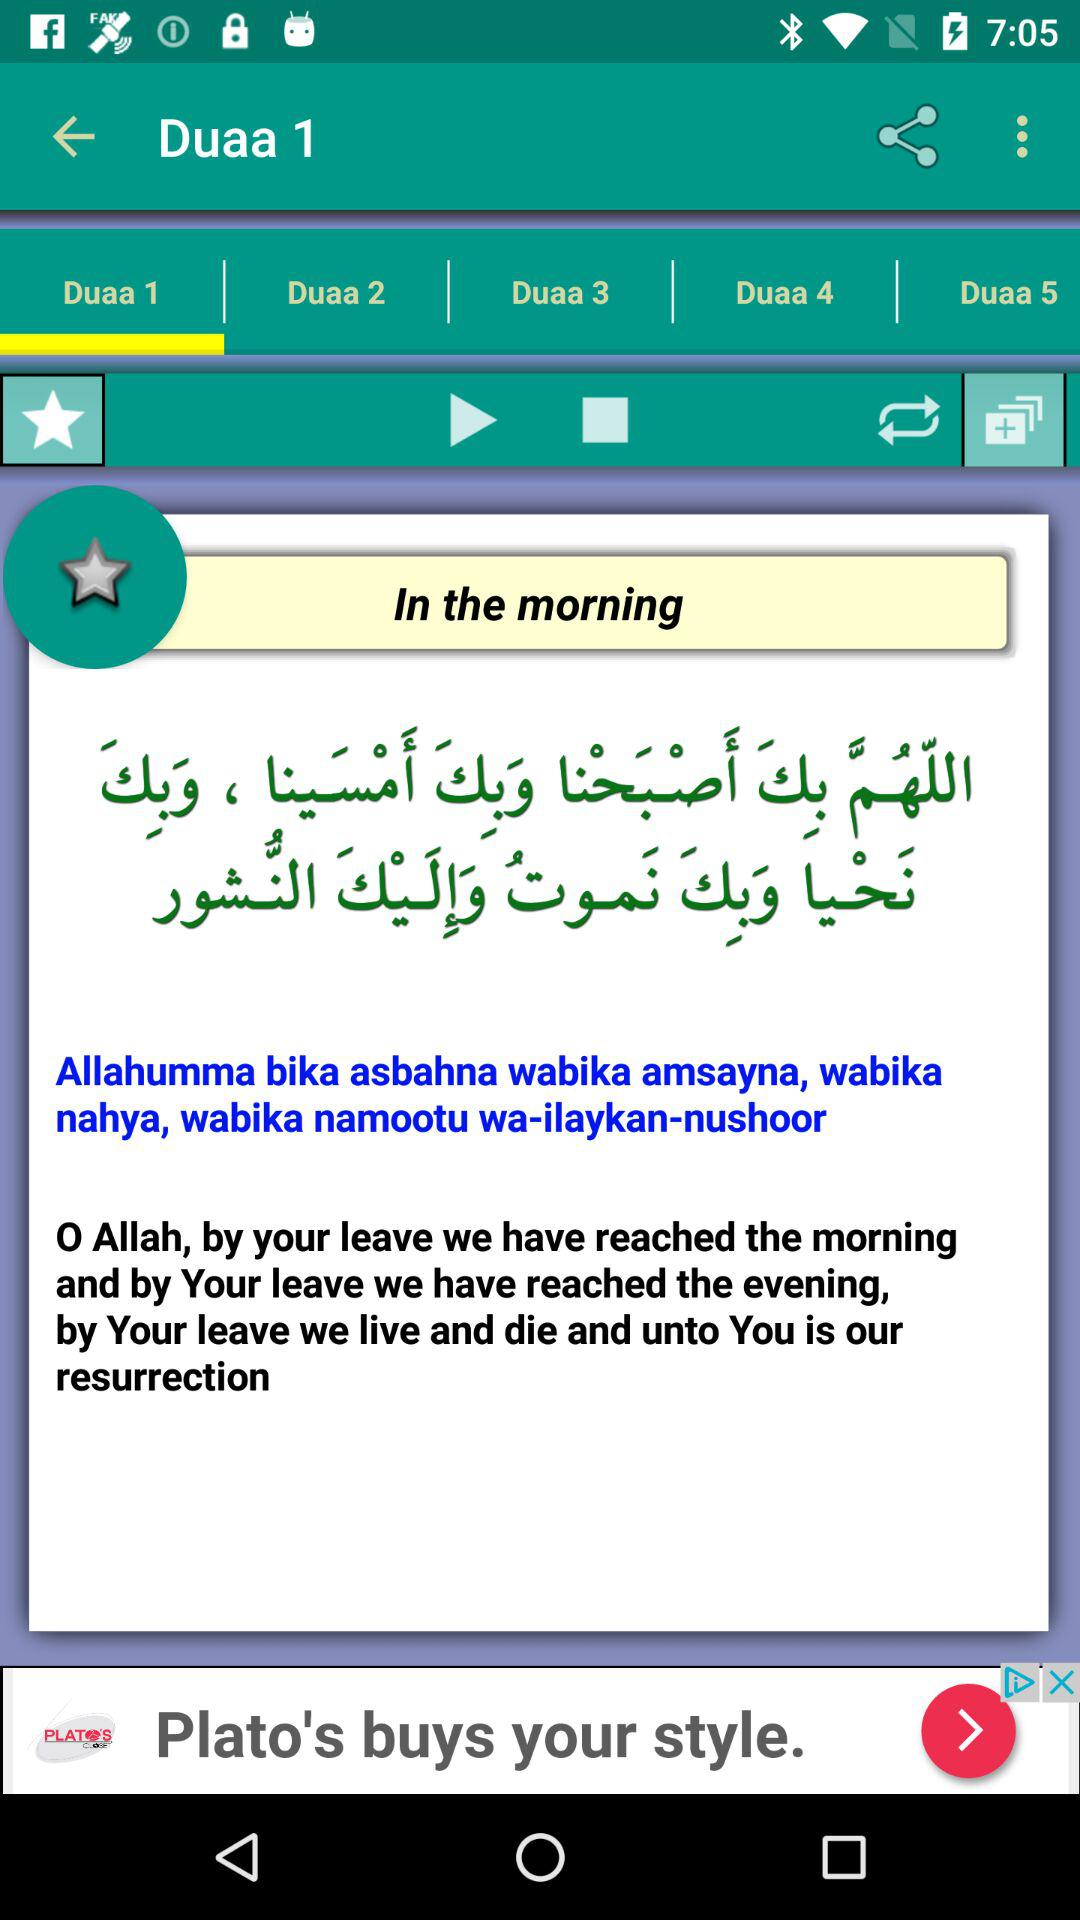Who wrote this prayer?
When the provided information is insufficient, respond with <no answer>. <no answer> 